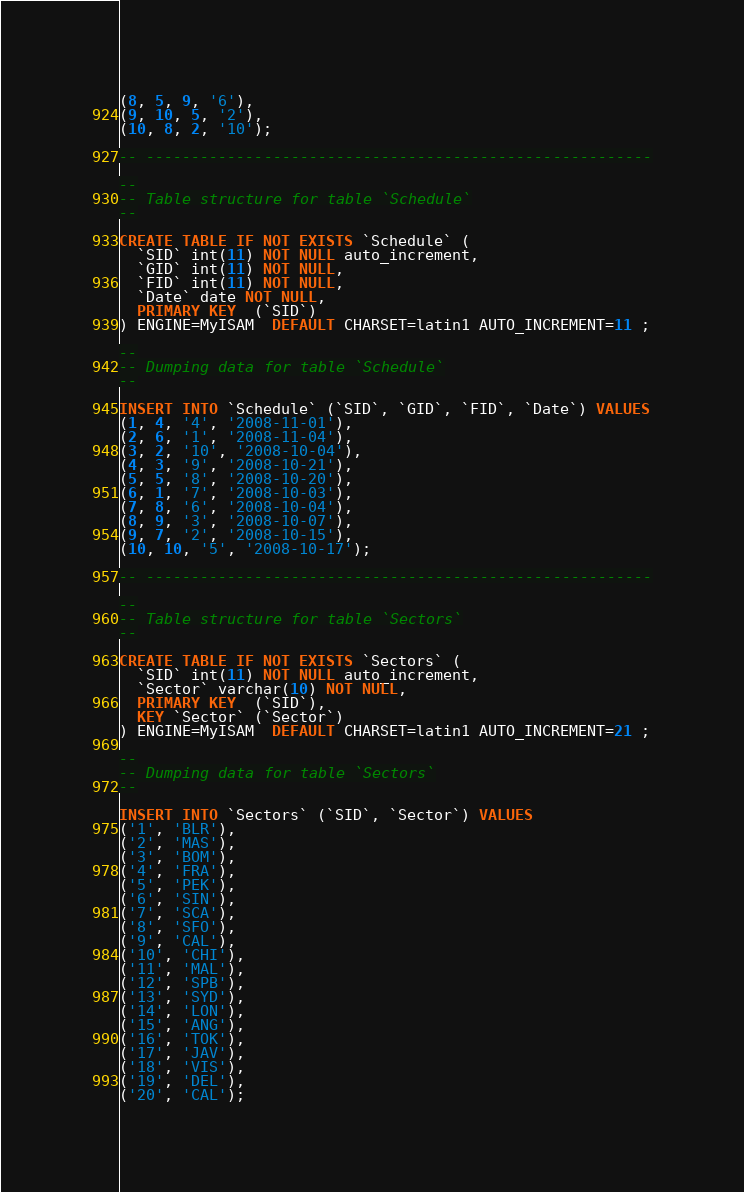<code> <loc_0><loc_0><loc_500><loc_500><_SQL_>(8, 5, 9, '6'),
(9, 10, 5, '2'),
(10, 8, 2, '10');

-- --------------------------------------------------------

--
-- Table structure for table `Schedule`
--

CREATE TABLE IF NOT EXISTS `Schedule` (
  `SID` int(11) NOT NULL auto_increment,
  `GID` int(11) NOT NULL,
  `FID` int(11) NOT NULL,
  `Date` date NOT NULL,
  PRIMARY KEY  (`SID`)
) ENGINE=MyISAM  DEFAULT CHARSET=latin1 AUTO_INCREMENT=11 ;

--
-- Dumping data for table `Schedule`
--

INSERT INTO `Schedule` (`SID`, `GID`, `FID`, `Date`) VALUES
(1, 4, '4', '2008-11-01'),
(2, 6, '1', '2008-11-04'),
(3, 2, '10', '2008-10-04'),
(4, 3, '9', '2008-10-21'),
(5, 5, '8', '2008-10-20'),
(6, 1, '7', '2008-10-03'),
(7, 8, '6', '2008-10-04'),
(8, 9, '3', '2008-10-07'),
(9, 7, '2', '2008-10-15'),
(10, 10, '5', '2008-10-17');

-- --------------------------------------------------------

--
-- Table structure for table `Sectors`
--

CREATE TABLE IF NOT EXISTS `Sectors` (
  `SID` int(11) NOT NULL auto_increment,
  `Sector` varchar(10) NOT NULL,
  PRIMARY KEY  (`SID`),
  KEY `Sector` (`Sector`)
) ENGINE=MyISAM  DEFAULT CHARSET=latin1 AUTO_INCREMENT=21 ;

--
-- Dumping data for table `Sectors`
--

INSERT INTO `Sectors` (`SID`, `Sector`) VALUES
('1', 'BLR'),
('2', 'MAS'),
('3', 'BOM'),
('4', 'FRA'),
('5', 'PEK'),
('6', 'SIN'),
('7', 'SCA'),
('8', 'SFO'),
('9', 'CAL'),
('10', 'CHI'),
('11', 'MAL'),
('12', 'SPB'),
('13', 'SYD'),
('14', 'LON'),
('15', 'ANG'),
('16', 'TOK'),
('17', 'JAV'),
('18', 'VIS'),
('19', 'DEL'),
('20', 'CAL');

</code> 